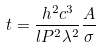<formula> <loc_0><loc_0><loc_500><loc_500>t = \frac { h ^ { 2 } c ^ { 3 } } { l P ^ { 2 } \lambda ^ { 2 } } \frac { A } { \sigma }</formula> 